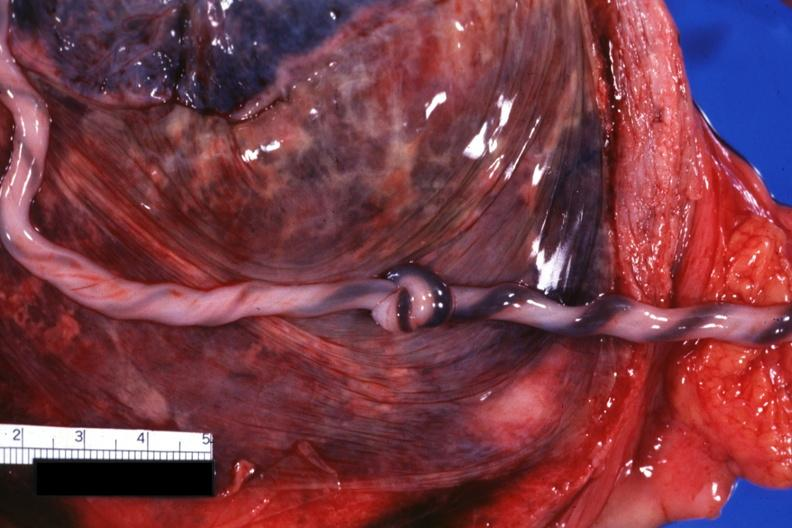what is present?
Answer the question using a single word or phrase. Umbilical cord 